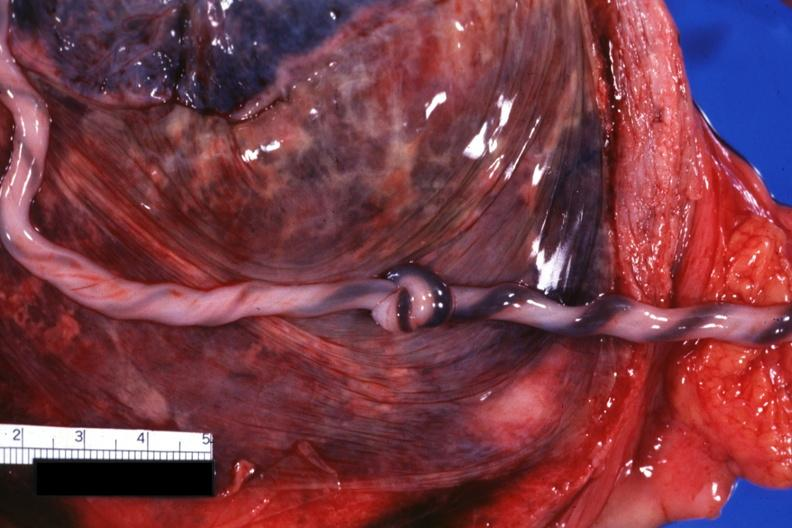what is present?
Answer the question using a single word or phrase. Umbilical cord 